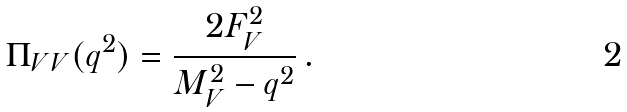<formula> <loc_0><loc_0><loc_500><loc_500>\Pi _ { V V } ( q ^ { 2 } ) = \frac { 2 F _ { V } ^ { 2 } } { M _ { V } ^ { 2 } - q ^ { 2 } } \, .</formula> 